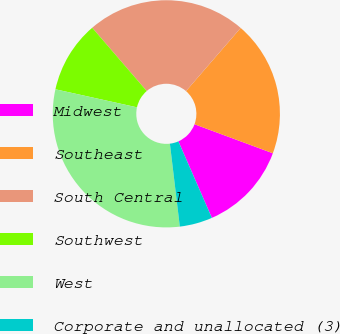Convert chart to OTSL. <chart><loc_0><loc_0><loc_500><loc_500><pie_chart><fcel>Midwest<fcel>Southeast<fcel>South Central<fcel>Southwest<fcel>West<fcel>Corporate and unallocated (3)<nl><fcel>12.79%<fcel>19.29%<fcel>22.67%<fcel>10.22%<fcel>30.36%<fcel>4.67%<nl></chart> 